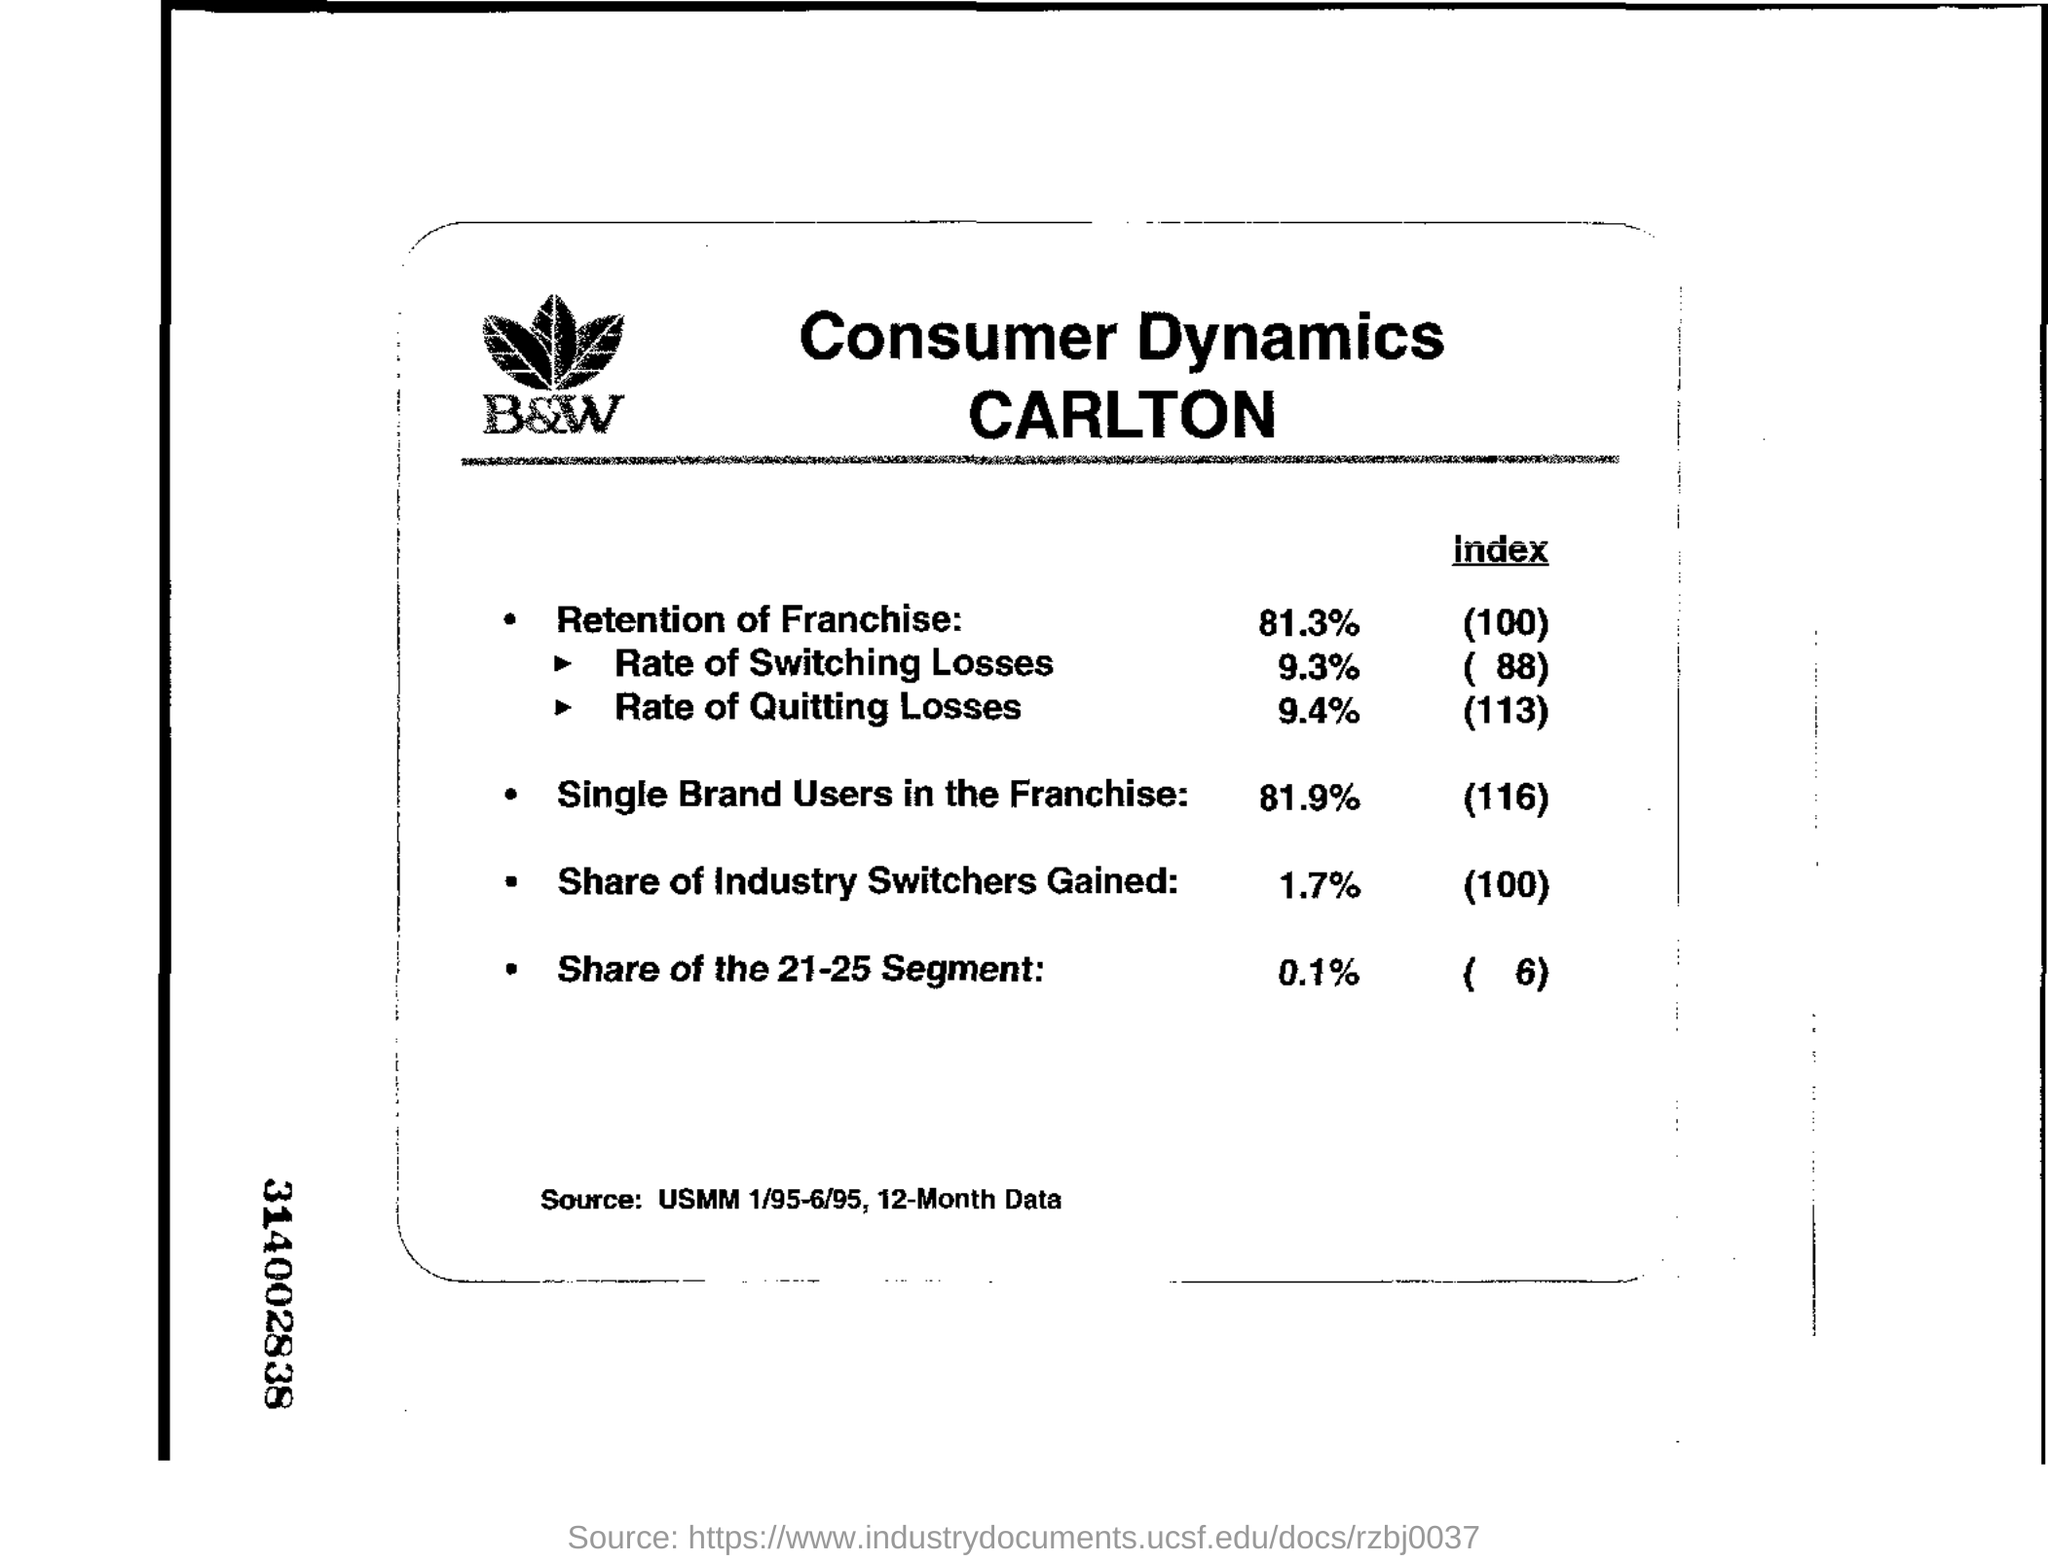Indicate a few pertinent items in this graphic. The index for the retention of franchise is 100. The source for the data is the Uniform Mortality Tables for the Year 1995, which provides 12-month data. The number located to the right of the left margin is 3,140,028,383... 